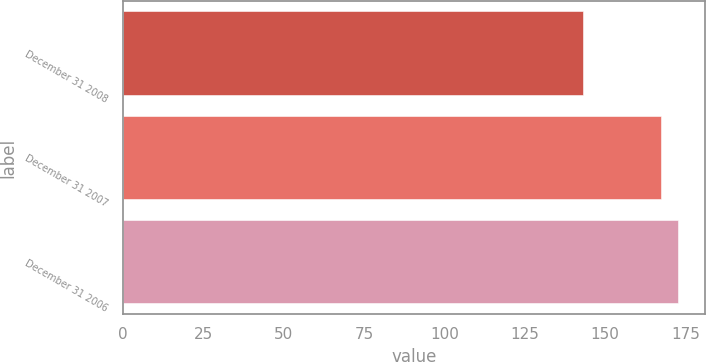<chart> <loc_0><loc_0><loc_500><loc_500><bar_chart><fcel>December 31 2008<fcel>December 31 2007<fcel>December 31 2006<nl><fcel>143<fcel>167.3<fcel>172.5<nl></chart> 